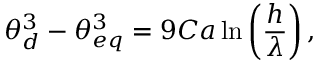Convert formula to latex. <formula><loc_0><loc_0><loc_500><loc_500>\theta _ { d } ^ { 3 } - \theta _ { e q } ^ { 3 } = 9 C a \ln \left ( \frac { h } { \lambda } \right ) ,</formula> 